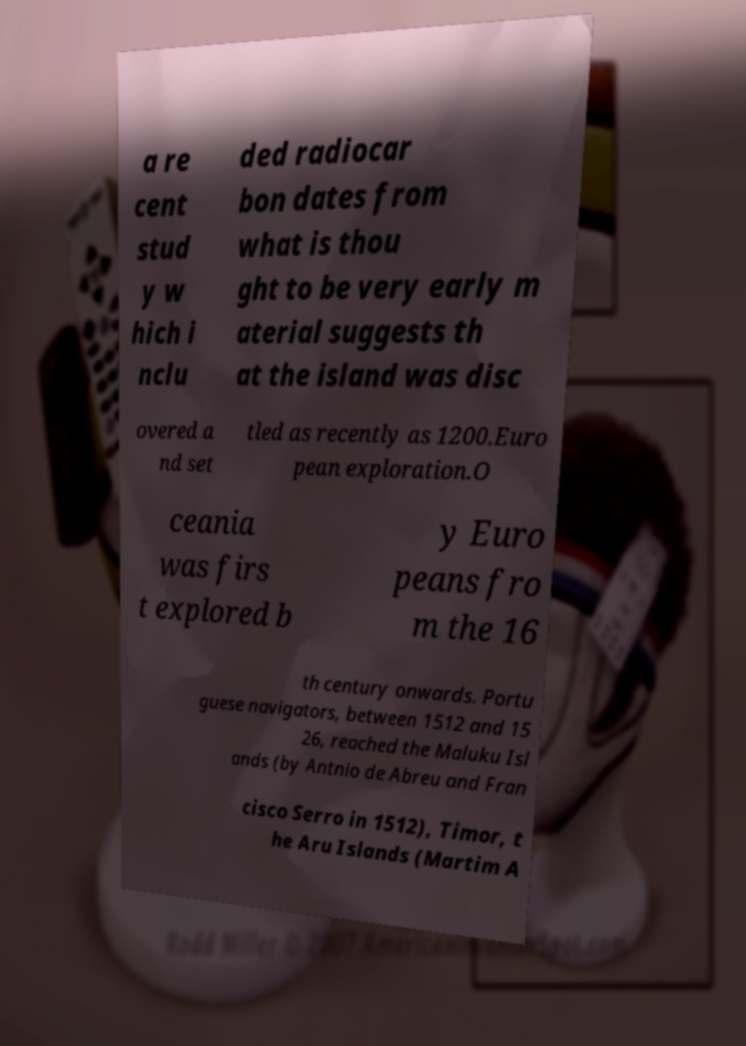Can you accurately transcribe the text from the provided image for me? a re cent stud y w hich i nclu ded radiocar bon dates from what is thou ght to be very early m aterial suggests th at the island was disc overed a nd set tled as recently as 1200.Euro pean exploration.O ceania was firs t explored b y Euro peans fro m the 16 th century onwards. Portu guese navigators, between 1512 and 15 26, reached the Maluku Isl ands (by Antnio de Abreu and Fran cisco Serro in 1512), Timor, t he Aru Islands (Martim A 